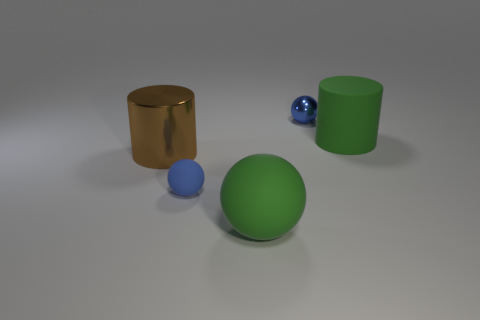The matte ball that is the same size as the green cylinder is what color?
Your answer should be compact. Green. How many other things are the same color as the metallic ball?
Offer a terse response. 1. Are there more tiny objects right of the green matte cylinder than tiny rubber cubes?
Make the answer very short. No. Are the brown cylinder and the green cylinder made of the same material?
Offer a very short reply. No. What number of things are either big objects that are on the left side of the green cylinder or large green cylinders?
Provide a succinct answer. 3. How many other things are there of the same size as the green cylinder?
Provide a succinct answer. 2. Are there the same number of green things that are in front of the big green sphere and rubber spheres that are behind the green matte cylinder?
Provide a short and direct response. Yes. There is a large matte thing that is the same shape as the small blue metallic object; what color is it?
Keep it short and to the point. Green. Do the large matte thing that is left of the metallic ball and the big matte cylinder have the same color?
Your answer should be compact. Yes. There is another blue object that is the same shape as the blue metallic thing; what is its size?
Ensure brevity in your answer.  Small. 